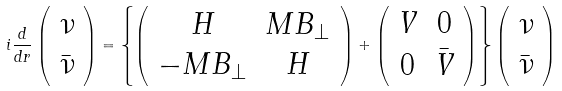Convert formula to latex. <formula><loc_0><loc_0><loc_500><loc_500>i \frac { d } { d r } \left ( \begin{array} { c } \nu \\ \bar { \nu } \end{array} \right ) = \left \{ \left ( \begin{array} { c c } H & M B _ { \bot } \\ - M B _ { \bot } & H \end{array} \right ) + \left ( \begin{array} { c c } V & 0 \\ 0 & \bar { V } \end{array} \right ) \right \} \left ( \begin{array} { c } \nu \\ \bar { \nu } \end{array} \right )</formula> 